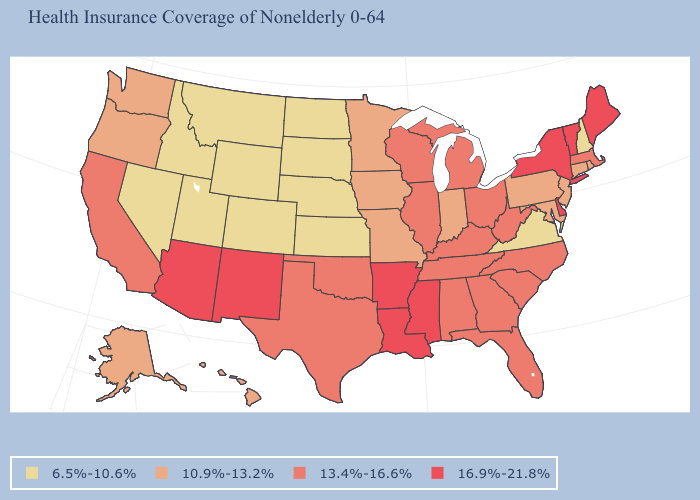Among the states that border West Virginia , does Ohio have the highest value?
Keep it brief. Yes. What is the value of Maryland?
Short answer required. 10.9%-13.2%. How many symbols are there in the legend?
Keep it brief. 4. Name the states that have a value in the range 10.9%-13.2%?
Be succinct. Alaska, Connecticut, Hawaii, Indiana, Iowa, Maryland, Minnesota, Missouri, New Jersey, Oregon, Pennsylvania, Rhode Island, Washington. What is the value of Arizona?
Write a very short answer. 16.9%-21.8%. What is the lowest value in the South?
Keep it brief. 6.5%-10.6%. What is the lowest value in the MidWest?
Keep it brief. 6.5%-10.6%. Does Vermont have the highest value in the Northeast?
Quick response, please. Yes. Does North Dakota have a higher value than Colorado?
Keep it brief. No. Name the states that have a value in the range 13.4%-16.6%?
Quick response, please. Alabama, California, Florida, Georgia, Illinois, Kentucky, Massachusetts, Michigan, North Carolina, Ohio, Oklahoma, South Carolina, Tennessee, Texas, West Virginia, Wisconsin. Which states have the highest value in the USA?
Short answer required. Arizona, Arkansas, Delaware, Louisiana, Maine, Mississippi, New Mexico, New York, Vermont. What is the value of Connecticut?
Answer briefly. 10.9%-13.2%. Does Maryland have the highest value in the South?
Concise answer only. No. Which states have the lowest value in the USA?
Short answer required. Colorado, Idaho, Kansas, Montana, Nebraska, Nevada, New Hampshire, North Dakota, South Dakota, Utah, Virginia, Wyoming. Is the legend a continuous bar?
Concise answer only. No. 